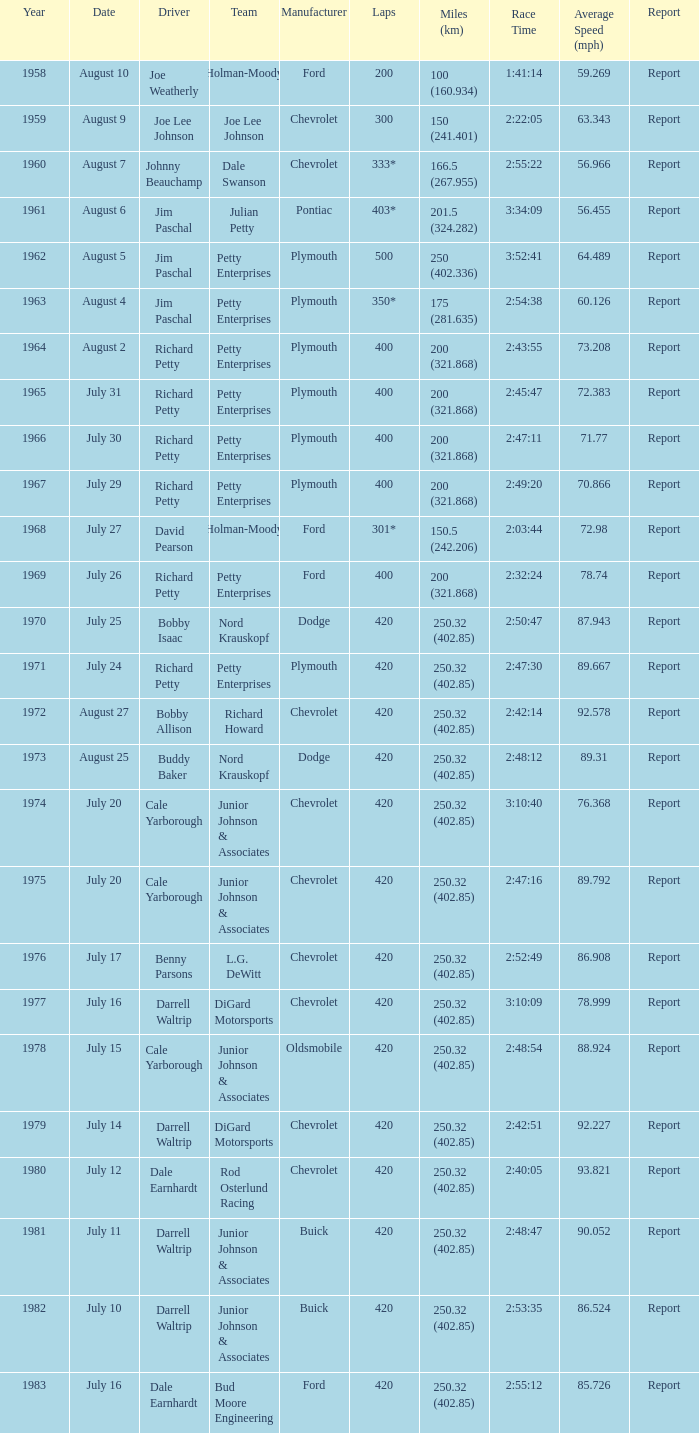How many miles were driven in the race where the winner finished in 2:47:11? 200 (321.868). 